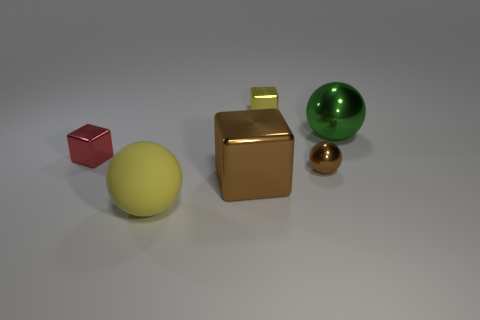Is the number of small metal blocks greater than the number of small shiny objects?
Give a very brief answer. No. How many green objects have the same size as the brown shiny ball?
Provide a succinct answer. 0. What is the shape of the small object that is the same color as the large metallic cube?
Offer a very short reply. Sphere. How many objects are tiny metallic blocks on the left side of the big brown metal block or small green matte cylinders?
Offer a terse response. 1. Is the number of big brown cubes less than the number of cubes?
Provide a succinct answer. Yes. What shape is the big green object that is made of the same material as the tiny yellow thing?
Provide a succinct answer. Sphere. There is a brown ball; are there any tiny red metallic things in front of it?
Provide a succinct answer. No. Is the number of yellow metallic objects that are behind the small yellow metal block less than the number of tiny yellow shiny cylinders?
Ensure brevity in your answer.  No. What material is the small yellow cube?
Your answer should be very brief. Metal. What is the color of the big rubber thing?
Offer a terse response. Yellow. 